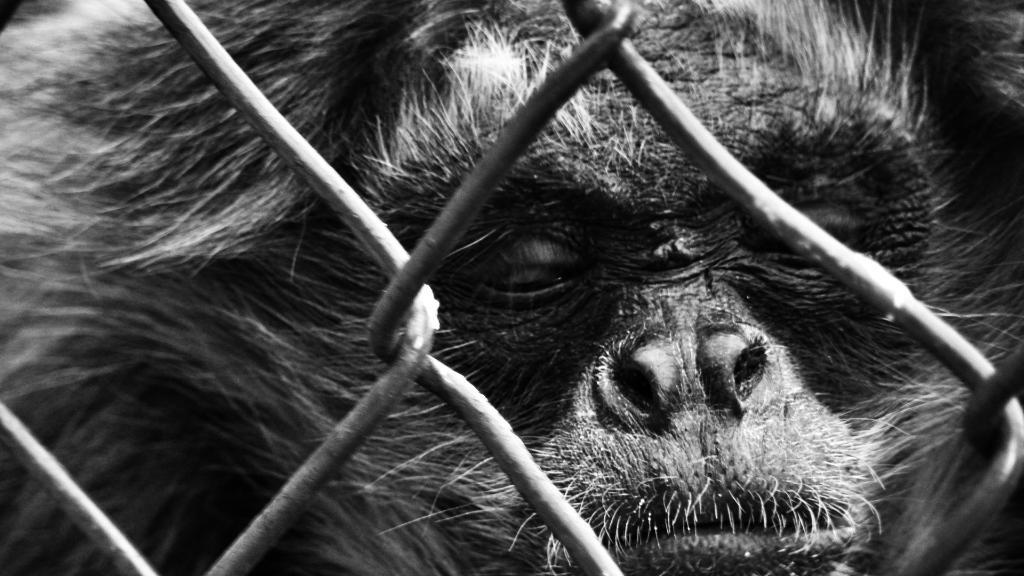What type of animal is in the image? There is a chimpanzee in the image. What objects can be seen in the image besides the chimpanzee? There are rods in the image. What is the chimpanzee's level of anger in the image? There is no indication of the chimpanzee's emotional state in the image, so it cannot be determined. 